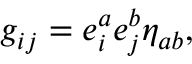Convert formula to latex. <formula><loc_0><loc_0><loc_500><loc_500>g _ { i j } = e _ { i } ^ { a } e _ { j } ^ { b } \eta _ { a b } ,</formula> 